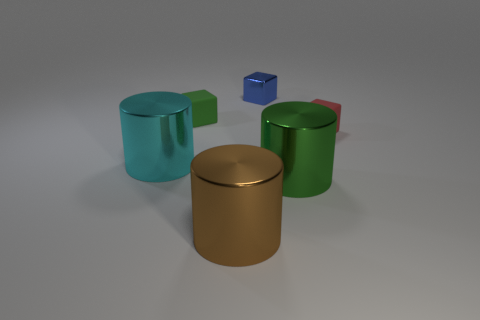Are there any large red objects that have the same material as the big green thing?
Make the answer very short. No. There is a brown thing; what shape is it?
Offer a terse response. Cylinder. How many big green shiny objects are there?
Give a very brief answer. 1. The small block in front of the tiny rubber object on the left side of the large brown thing is what color?
Your response must be concise. Red. What color is the shiny block that is the same size as the red thing?
Your response must be concise. Blue. Are there any big brown shiny things?
Ensure brevity in your answer.  Yes. What shape is the shiny thing on the left side of the green rubber thing?
Your answer should be very brief. Cylinder. How many things are to the left of the small red cube and right of the blue shiny thing?
Provide a short and direct response. 1. There is a green object behind the cyan metallic object; is its shape the same as the tiny red object right of the small blue cube?
Offer a terse response. Yes. How many things are either red matte things or things on the right side of the green block?
Provide a short and direct response. 4. 